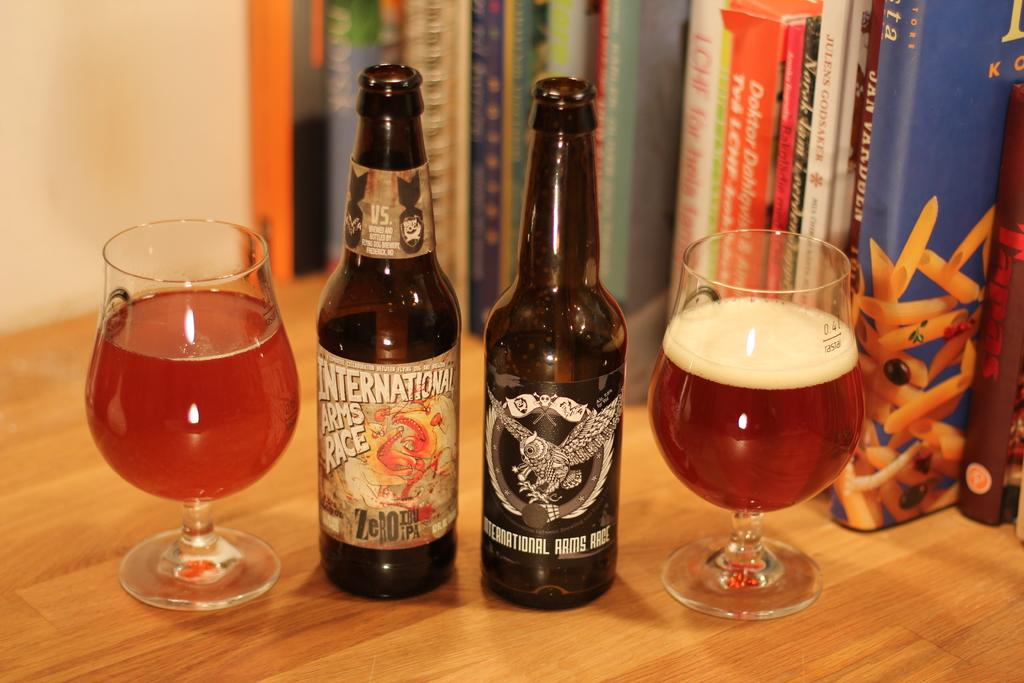<image>
Relay a brief, clear account of the picture shown. Two bottles of brand international arms race beer sit next to two full glasses. 